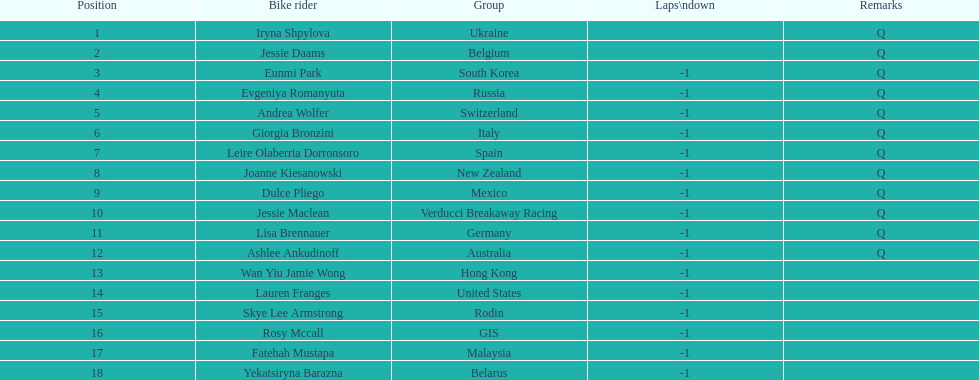What team is listed previous to belgium? Ukraine. 